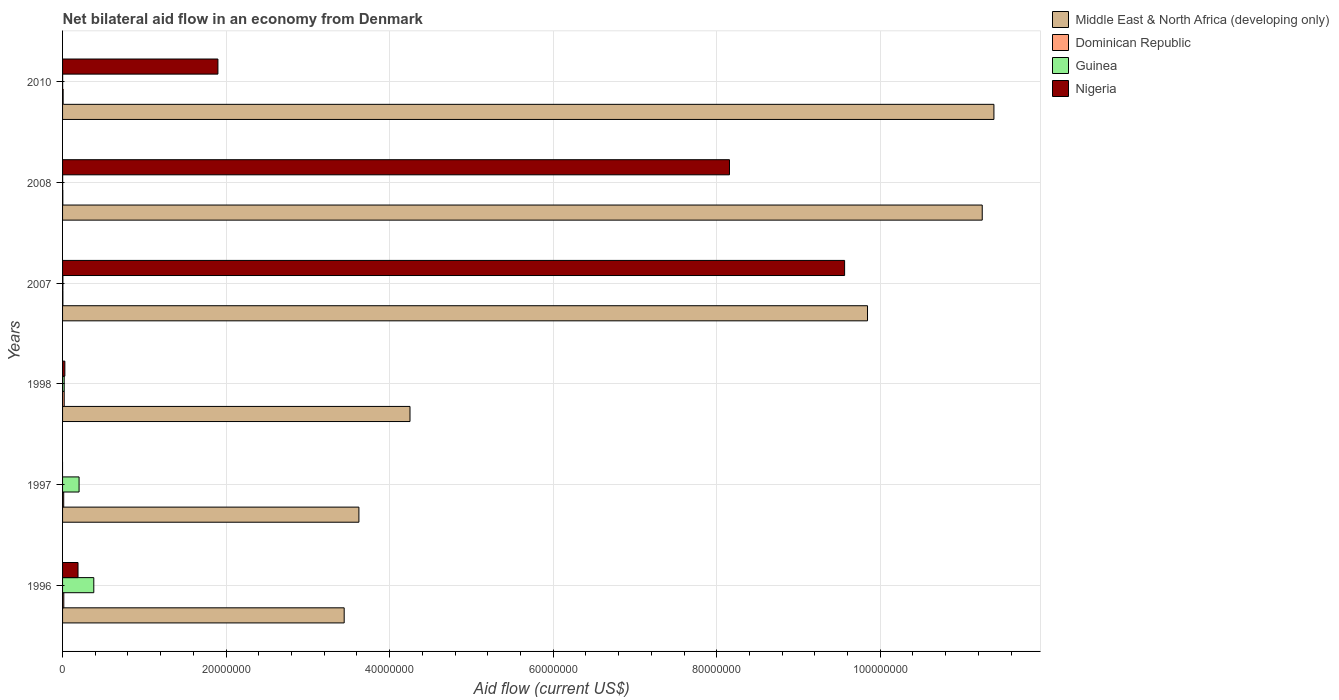How many different coloured bars are there?
Provide a short and direct response. 4. What is the net bilateral aid flow in Guinea in 1998?
Give a very brief answer. 2.00e+05. Across all years, what is the maximum net bilateral aid flow in Nigeria?
Give a very brief answer. 9.56e+07. Across all years, what is the minimum net bilateral aid flow in Dominican Republic?
Provide a succinct answer. 3.00e+04. What is the total net bilateral aid flow in Guinea in the graph?
Give a very brief answer. 6.10e+06. What is the difference between the net bilateral aid flow in Guinea in 1996 and that in 1998?
Provide a succinct answer. 3.62e+06. What is the difference between the net bilateral aid flow in Middle East & North Africa (developing only) in 2010 and the net bilateral aid flow in Guinea in 1997?
Provide a succinct answer. 1.12e+08. What is the average net bilateral aid flow in Dominican Republic per year?
Your answer should be very brief. 1.05e+05. In the year 1998, what is the difference between the net bilateral aid flow in Nigeria and net bilateral aid flow in Middle East & North Africa (developing only)?
Your response must be concise. -4.22e+07. In how many years, is the net bilateral aid flow in Nigeria greater than 16000000 US$?
Give a very brief answer. 3. What is the ratio of the net bilateral aid flow in Dominican Republic in 1998 to that in 2007?
Your response must be concise. 5. What is the difference between the highest and the second highest net bilateral aid flow in Nigeria?
Your answer should be very brief. 1.41e+07. Is the sum of the net bilateral aid flow in Dominican Republic in 1997 and 2010 greater than the maximum net bilateral aid flow in Guinea across all years?
Your answer should be compact. No. Is it the case that in every year, the sum of the net bilateral aid flow in Dominican Republic and net bilateral aid flow in Nigeria is greater than the sum of net bilateral aid flow in Guinea and net bilateral aid flow in Middle East & North Africa (developing only)?
Your response must be concise. No. Is it the case that in every year, the sum of the net bilateral aid flow in Dominican Republic and net bilateral aid flow in Guinea is greater than the net bilateral aid flow in Nigeria?
Offer a terse response. No. Are all the bars in the graph horizontal?
Provide a short and direct response. Yes. How many years are there in the graph?
Ensure brevity in your answer.  6. Does the graph contain any zero values?
Provide a succinct answer. Yes. Does the graph contain grids?
Ensure brevity in your answer.  Yes. How many legend labels are there?
Offer a terse response. 4. What is the title of the graph?
Ensure brevity in your answer.  Net bilateral aid flow in an economy from Denmark. What is the label or title of the Y-axis?
Your answer should be compact. Years. What is the Aid flow (current US$) of Middle East & North Africa (developing only) in 1996?
Your answer should be very brief. 3.44e+07. What is the Aid flow (current US$) of Guinea in 1996?
Provide a succinct answer. 3.82e+06. What is the Aid flow (current US$) in Nigeria in 1996?
Offer a very short reply. 1.89e+06. What is the Aid flow (current US$) in Middle East & North Africa (developing only) in 1997?
Make the answer very short. 3.62e+07. What is the Aid flow (current US$) of Guinea in 1997?
Ensure brevity in your answer.  2.02e+06. What is the Aid flow (current US$) of Middle East & North Africa (developing only) in 1998?
Give a very brief answer. 4.25e+07. What is the Aid flow (current US$) in Middle East & North Africa (developing only) in 2007?
Provide a short and direct response. 9.84e+07. What is the Aid flow (current US$) of Nigeria in 2007?
Ensure brevity in your answer.  9.56e+07. What is the Aid flow (current US$) of Middle East & North Africa (developing only) in 2008?
Keep it short and to the point. 1.12e+08. What is the Aid flow (current US$) in Nigeria in 2008?
Your response must be concise. 8.16e+07. What is the Aid flow (current US$) in Middle East & North Africa (developing only) in 2010?
Make the answer very short. 1.14e+08. What is the Aid flow (current US$) in Dominican Republic in 2010?
Keep it short and to the point. 7.00e+04. What is the Aid flow (current US$) of Guinea in 2010?
Your answer should be very brief. 10000. What is the Aid flow (current US$) in Nigeria in 2010?
Give a very brief answer. 1.90e+07. Across all years, what is the maximum Aid flow (current US$) of Middle East & North Africa (developing only)?
Your answer should be very brief. 1.14e+08. Across all years, what is the maximum Aid flow (current US$) in Guinea?
Make the answer very short. 3.82e+06. Across all years, what is the maximum Aid flow (current US$) of Nigeria?
Provide a short and direct response. 9.56e+07. Across all years, what is the minimum Aid flow (current US$) in Middle East & North Africa (developing only)?
Provide a short and direct response. 3.44e+07. What is the total Aid flow (current US$) in Middle East & North Africa (developing only) in the graph?
Your answer should be very brief. 4.38e+08. What is the total Aid flow (current US$) of Dominican Republic in the graph?
Offer a terse response. 6.30e+05. What is the total Aid flow (current US$) of Guinea in the graph?
Ensure brevity in your answer.  6.10e+06. What is the total Aid flow (current US$) in Nigeria in the graph?
Provide a succinct answer. 1.98e+08. What is the difference between the Aid flow (current US$) of Middle East & North Africa (developing only) in 1996 and that in 1997?
Give a very brief answer. -1.80e+06. What is the difference between the Aid flow (current US$) in Guinea in 1996 and that in 1997?
Offer a terse response. 1.80e+06. What is the difference between the Aid flow (current US$) of Middle East & North Africa (developing only) in 1996 and that in 1998?
Provide a short and direct response. -8.05e+06. What is the difference between the Aid flow (current US$) of Dominican Republic in 1996 and that in 1998?
Keep it short and to the point. -5.00e+04. What is the difference between the Aid flow (current US$) in Guinea in 1996 and that in 1998?
Make the answer very short. 3.62e+06. What is the difference between the Aid flow (current US$) in Nigeria in 1996 and that in 1998?
Provide a short and direct response. 1.61e+06. What is the difference between the Aid flow (current US$) of Middle East & North Africa (developing only) in 1996 and that in 2007?
Offer a very short reply. -6.40e+07. What is the difference between the Aid flow (current US$) of Dominican Republic in 1996 and that in 2007?
Provide a short and direct response. 1.10e+05. What is the difference between the Aid flow (current US$) in Guinea in 1996 and that in 2007?
Keep it short and to the point. 3.78e+06. What is the difference between the Aid flow (current US$) in Nigeria in 1996 and that in 2007?
Provide a short and direct response. -9.38e+07. What is the difference between the Aid flow (current US$) of Middle East & North Africa (developing only) in 1996 and that in 2008?
Give a very brief answer. -7.80e+07. What is the difference between the Aid flow (current US$) of Dominican Republic in 1996 and that in 2008?
Make the answer very short. 1.20e+05. What is the difference between the Aid flow (current US$) in Guinea in 1996 and that in 2008?
Keep it short and to the point. 3.81e+06. What is the difference between the Aid flow (current US$) in Nigeria in 1996 and that in 2008?
Ensure brevity in your answer.  -7.97e+07. What is the difference between the Aid flow (current US$) in Middle East & North Africa (developing only) in 1996 and that in 2010?
Provide a short and direct response. -7.95e+07. What is the difference between the Aid flow (current US$) of Dominican Republic in 1996 and that in 2010?
Your answer should be very brief. 8.00e+04. What is the difference between the Aid flow (current US$) of Guinea in 1996 and that in 2010?
Give a very brief answer. 3.81e+06. What is the difference between the Aid flow (current US$) of Nigeria in 1996 and that in 2010?
Provide a succinct answer. -1.71e+07. What is the difference between the Aid flow (current US$) in Middle East & North Africa (developing only) in 1997 and that in 1998?
Offer a terse response. -6.25e+06. What is the difference between the Aid flow (current US$) in Guinea in 1997 and that in 1998?
Keep it short and to the point. 1.82e+06. What is the difference between the Aid flow (current US$) of Middle East & North Africa (developing only) in 1997 and that in 2007?
Give a very brief answer. -6.22e+07. What is the difference between the Aid flow (current US$) in Dominican Republic in 1997 and that in 2007?
Provide a succinct answer. 1.00e+05. What is the difference between the Aid flow (current US$) in Guinea in 1997 and that in 2007?
Your answer should be compact. 1.98e+06. What is the difference between the Aid flow (current US$) of Middle East & North Africa (developing only) in 1997 and that in 2008?
Your response must be concise. -7.62e+07. What is the difference between the Aid flow (current US$) of Dominican Republic in 1997 and that in 2008?
Your answer should be very brief. 1.10e+05. What is the difference between the Aid flow (current US$) in Guinea in 1997 and that in 2008?
Make the answer very short. 2.01e+06. What is the difference between the Aid flow (current US$) in Middle East & North Africa (developing only) in 1997 and that in 2010?
Your answer should be compact. -7.77e+07. What is the difference between the Aid flow (current US$) in Guinea in 1997 and that in 2010?
Your response must be concise. 2.01e+06. What is the difference between the Aid flow (current US$) of Middle East & North Africa (developing only) in 1998 and that in 2007?
Keep it short and to the point. -5.60e+07. What is the difference between the Aid flow (current US$) of Nigeria in 1998 and that in 2007?
Provide a succinct answer. -9.54e+07. What is the difference between the Aid flow (current US$) of Middle East & North Africa (developing only) in 1998 and that in 2008?
Offer a very short reply. -7.00e+07. What is the difference between the Aid flow (current US$) of Dominican Republic in 1998 and that in 2008?
Keep it short and to the point. 1.70e+05. What is the difference between the Aid flow (current US$) in Guinea in 1998 and that in 2008?
Your answer should be compact. 1.90e+05. What is the difference between the Aid flow (current US$) of Nigeria in 1998 and that in 2008?
Your answer should be very brief. -8.13e+07. What is the difference between the Aid flow (current US$) of Middle East & North Africa (developing only) in 1998 and that in 2010?
Your answer should be very brief. -7.14e+07. What is the difference between the Aid flow (current US$) in Guinea in 1998 and that in 2010?
Your answer should be very brief. 1.90e+05. What is the difference between the Aid flow (current US$) in Nigeria in 1998 and that in 2010?
Your answer should be very brief. -1.87e+07. What is the difference between the Aid flow (current US$) of Middle East & North Africa (developing only) in 2007 and that in 2008?
Make the answer very short. -1.40e+07. What is the difference between the Aid flow (current US$) in Dominican Republic in 2007 and that in 2008?
Offer a very short reply. 10000. What is the difference between the Aid flow (current US$) of Guinea in 2007 and that in 2008?
Ensure brevity in your answer.  3.00e+04. What is the difference between the Aid flow (current US$) in Nigeria in 2007 and that in 2008?
Offer a terse response. 1.41e+07. What is the difference between the Aid flow (current US$) in Middle East & North Africa (developing only) in 2007 and that in 2010?
Offer a terse response. -1.55e+07. What is the difference between the Aid flow (current US$) of Dominican Republic in 2007 and that in 2010?
Your response must be concise. -3.00e+04. What is the difference between the Aid flow (current US$) of Nigeria in 2007 and that in 2010?
Make the answer very short. 7.66e+07. What is the difference between the Aid flow (current US$) in Middle East & North Africa (developing only) in 2008 and that in 2010?
Provide a succinct answer. -1.43e+06. What is the difference between the Aid flow (current US$) in Dominican Republic in 2008 and that in 2010?
Ensure brevity in your answer.  -4.00e+04. What is the difference between the Aid flow (current US$) of Guinea in 2008 and that in 2010?
Provide a succinct answer. 0. What is the difference between the Aid flow (current US$) of Nigeria in 2008 and that in 2010?
Give a very brief answer. 6.26e+07. What is the difference between the Aid flow (current US$) of Middle East & North Africa (developing only) in 1996 and the Aid flow (current US$) of Dominican Republic in 1997?
Make the answer very short. 3.43e+07. What is the difference between the Aid flow (current US$) in Middle East & North Africa (developing only) in 1996 and the Aid flow (current US$) in Guinea in 1997?
Offer a terse response. 3.24e+07. What is the difference between the Aid flow (current US$) in Dominican Republic in 1996 and the Aid flow (current US$) in Guinea in 1997?
Provide a succinct answer. -1.87e+06. What is the difference between the Aid flow (current US$) in Middle East & North Africa (developing only) in 1996 and the Aid flow (current US$) in Dominican Republic in 1998?
Make the answer very short. 3.42e+07. What is the difference between the Aid flow (current US$) of Middle East & North Africa (developing only) in 1996 and the Aid flow (current US$) of Guinea in 1998?
Your response must be concise. 3.42e+07. What is the difference between the Aid flow (current US$) of Middle East & North Africa (developing only) in 1996 and the Aid flow (current US$) of Nigeria in 1998?
Provide a short and direct response. 3.42e+07. What is the difference between the Aid flow (current US$) in Dominican Republic in 1996 and the Aid flow (current US$) in Guinea in 1998?
Make the answer very short. -5.00e+04. What is the difference between the Aid flow (current US$) in Guinea in 1996 and the Aid flow (current US$) in Nigeria in 1998?
Your response must be concise. 3.54e+06. What is the difference between the Aid flow (current US$) of Middle East & North Africa (developing only) in 1996 and the Aid flow (current US$) of Dominican Republic in 2007?
Provide a succinct answer. 3.44e+07. What is the difference between the Aid flow (current US$) of Middle East & North Africa (developing only) in 1996 and the Aid flow (current US$) of Guinea in 2007?
Ensure brevity in your answer.  3.44e+07. What is the difference between the Aid flow (current US$) of Middle East & North Africa (developing only) in 1996 and the Aid flow (current US$) of Nigeria in 2007?
Provide a succinct answer. -6.12e+07. What is the difference between the Aid flow (current US$) in Dominican Republic in 1996 and the Aid flow (current US$) in Guinea in 2007?
Your answer should be very brief. 1.10e+05. What is the difference between the Aid flow (current US$) in Dominican Republic in 1996 and the Aid flow (current US$) in Nigeria in 2007?
Provide a succinct answer. -9.55e+07. What is the difference between the Aid flow (current US$) in Guinea in 1996 and the Aid flow (current US$) in Nigeria in 2007?
Ensure brevity in your answer.  -9.18e+07. What is the difference between the Aid flow (current US$) of Middle East & North Africa (developing only) in 1996 and the Aid flow (current US$) of Dominican Republic in 2008?
Give a very brief answer. 3.44e+07. What is the difference between the Aid flow (current US$) of Middle East & North Africa (developing only) in 1996 and the Aid flow (current US$) of Guinea in 2008?
Offer a very short reply. 3.44e+07. What is the difference between the Aid flow (current US$) of Middle East & North Africa (developing only) in 1996 and the Aid flow (current US$) of Nigeria in 2008?
Offer a terse response. -4.71e+07. What is the difference between the Aid flow (current US$) in Dominican Republic in 1996 and the Aid flow (current US$) in Guinea in 2008?
Your answer should be compact. 1.40e+05. What is the difference between the Aid flow (current US$) of Dominican Republic in 1996 and the Aid flow (current US$) of Nigeria in 2008?
Ensure brevity in your answer.  -8.14e+07. What is the difference between the Aid flow (current US$) of Guinea in 1996 and the Aid flow (current US$) of Nigeria in 2008?
Provide a short and direct response. -7.77e+07. What is the difference between the Aid flow (current US$) of Middle East & North Africa (developing only) in 1996 and the Aid flow (current US$) of Dominican Republic in 2010?
Your answer should be compact. 3.44e+07. What is the difference between the Aid flow (current US$) of Middle East & North Africa (developing only) in 1996 and the Aid flow (current US$) of Guinea in 2010?
Your response must be concise. 3.44e+07. What is the difference between the Aid flow (current US$) of Middle East & North Africa (developing only) in 1996 and the Aid flow (current US$) of Nigeria in 2010?
Provide a succinct answer. 1.54e+07. What is the difference between the Aid flow (current US$) in Dominican Republic in 1996 and the Aid flow (current US$) in Guinea in 2010?
Your answer should be compact. 1.40e+05. What is the difference between the Aid flow (current US$) of Dominican Republic in 1996 and the Aid flow (current US$) of Nigeria in 2010?
Your answer should be compact. -1.88e+07. What is the difference between the Aid flow (current US$) in Guinea in 1996 and the Aid flow (current US$) in Nigeria in 2010?
Your answer should be compact. -1.52e+07. What is the difference between the Aid flow (current US$) in Middle East & North Africa (developing only) in 1997 and the Aid flow (current US$) in Dominican Republic in 1998?
Keep it short and to the point. 3.60e+07. What is the difference between the Aid flow (current US$) of Middle East & North Africa (developing only) in 1997 and the Aid flow (current US$) of Guinea in 1998?
Your response must be concise. 3.60e+07. What is the difference between the Aid flow (current US$) in Middle East & North Africa (developing only) in 1997 and the Aid flow (current US$) in Nigeria in 1998?
Keep it short and to the point. 3.60e+07. What is the difference between the Aid flow (current US$) in Dominican Republic in 1997 and the Aid flow (current US$) in Guinea in 1998?
Your answer should be compact. -6.00e+04. What is the difference between the Aid flow (current US$) of Guinea in 1997 and the Aid flow (current US$) of Nigeria in 1998?
Keep it short and to the point. 1.74e+06. What is the difference between the Aid flow (current US$) in Middle East & North Africa (developing only) in 1997 and the Aid flow (current US$) in Dominican Republic in 2007?
Keep it short and to the point. 3.62e+07. What is the difference between the Aid flow (current US$) in Middle East & North Africa (developing only) in 1997 and the Aid flow (current US$) in Guinea in 2007?
Your answer should be very brief. 3.62e+07. What is the difference between the Aid flow (current US$) of Middle East & North Africa (developing only) in 1997 and the Aid flow (current US$) of Nigeria in 2007?
Give a very brief answer. -5.94e+07. What is the difference between the Aid flow (current US$) of Dominican Republic in 1997 and the Aid flow (current US$) of Guinea in 2007?
Give a very brief answer. 1.00e+05. What is the difference between the Aid flow (current US$) of Dominican Republic in 1997 and the Aid flow (current US$) of Nigeria in 2007?
Ensure brevity in your answer.  -9.55e+07. What is the difference between the Aid flow (current US$) of Guinea in 1997 and the Aid flow (current US$) of Nigeria in 2007?
Give a very brief answer. -9.36e+07. What is the difference between the Aid flow (current US$) in Middle East & North Africa (developing only) in 1997 and the Aid flow (current US$) in Dominican Republic in 2008?
Your response must be concise. 3.62e+07. What is the difference between the Aid flow (current US$) in Middle East & North Africa (developing only) in 1997 and the Aid flow (current US$) in Guinea in 2008?
Make the answer very short. 3.62e+07. What is the difference between the Aid flow (current US$) of Middle East & North Africa (developing only) in 1997 and the Aid flow (current US$) of Nigeria in 2008?
Ensure brevity in your answer.  -4.53e+07. What is the difference between the Aid flow (current US$) in Dominican Republic in 1997 and the Aid flow (current US$) in Nigeria in 2008?
Give a very brief answer. -8.14e+07. What is the difference between the Aid flow (current US$) in Guinea in 1997 and the Aid flow (current US$) in Nigeria in 2008?
Your answer should be compact. -7.95e+07. What is the difference between the Aid flow (current US$) in Middle East & North Africa (developing only) in 1997 and the Aid flow (current US$) in Dominican Republic in 2010?
Ensure brevity in your answer.  3.62e+07. What is the difference between the Aid flow (current US$) of Middle East & North Africa (developing only) in 1997 and the Aid flow (current US$) of Guinea in 2010?
Offer a terse response. 3.62e+07. What is the difference between the Aid flow (current US$) in Middle East & North Africa (developing only) in 1997 and the Aid flow (current US$) in Nigeria in 2010?
Your answer should be compact. 1.72e+07. What is the difference between the Aid flow (current US$) of Dominican Republic in 1997 and the Aid flow (current US$) of Nigeria in 2010?
Provide a short and direct response. -1.89e+07. What is the difference between the Aid flow (current US$) of Guinea in 1997 and the Aid flow (current US$) of Nigeria in 2010?
Your response must be concise. -1.70e+07. What is the difference between the Aid flow (current US$) of Middle East & North Africa (developing only) in 1998 and the Aid flow (current US$) of Dominican Republic in 2007?
Keep it short and to the point. 4.24e+07. What is the difference between the Aid flow (current US$) of Middle East & North Africa (developing only) in 1998 and the Aid flow (current US$) of Guinea in 2007?
Provide a short and direct response. 4.24e+07. What is the difference between the Aid flow (current US$) of Middle East & North Africa (developing only) in 1998 and the Aid flow (current US$) of Nigeria in 2007?
Make the answer very short. -5.32e+07. What is the difference between the Aid flow (current US$) in Dominican Republic in 1998 and the Aid flow (current US$) in Guinea in 2007?
Offer a terse response. 1.60e+05. What is the difference between the Aid flow (current US$) in Dominican Republic in 1998 and the Aid flow (current US$) in Nigeria in 2007?
Keep it short and to the point. -9.54e+07. What is the difference between the Aid flow (current US$) in Guinea in 1998 and the Aid flow (current US$) in Nigeria in 2007?
Your response must be concise. -9.54e+07. What is the difference between the Aid flow (current US$) of Middle East & North Africa (developing only) in 1998 and the Aid flow (current US$) of Dominican Republic in 2008?
Provide a succinct answer. 4.25e+07. What is the difference between the Aid flow (current US$) in Middle East & North Africa (developing only) in 1998 and the Aid flow (current US$) in Guinea in 2008?
Make the answer very short. 4.25e+07. What is the difference between the Aid flow (current US$) of Middle East & North Africa (developing only) in 1998 and the Aid flow (current US$) of Nigeria in 2008?
Your answer should be very brief. -3.91e+07. What is the difference between the Aid flow (current US$) of Dominican Republic in 1998 and the Aid flow (current US$) of Nigeria in 2008?
Offer a very short reply. -8.14e+07. What is the difference between the Aid flow (current US$) of Guinea in 1998 and the Aid flow (current US$) of Nigeria in 2008?
Keep it short and to the point. -8.14e+07. What is the difference between the Aid flow (current US$) of Middle East & North Africa (developing only) in 1998 and the Aid flow (current US$) of Dominican Republic in 2010?
Make the answer very short. 4.24e+07. What is the difference between the Aid flow (current US$) in Middle East & North Africa (developing only) in 1998 and the Aid flow (current US$) in Guinea in 2010?
Keep it short and to the point. 4.25e+07. What is the difference between the Aid flow (current US$) of Middle East & North Africa (developing only) in 1998 and the Aid flow (current US$) of Nigeria in 2010?
Give a very brief answer. 2.35e+07. What is the difference between the Aid flow (current US$) of Dominican Republic in 1998 and the Aid flow (current US$) of Nigeria in 2010?
Offer a very short reply. -1.88e+07. What is the difference between the Aid flow (current US$) in Guinea in 1998 and the Aid flow (current US$) in Nigeria in 2010?
Provide a short and direct response. -1.88e+07. What is the difference between the Aid flow (current US$) of Middle East & North Africa (developing only) in 2007 and the Aid flow (current US$) of Dominican Republic in 2008?
Ensure brevity in your answer.  9.84e+07. What is the difference between the Aid flow (current US$) of Middle East & North Africa (developing only) in 2007 and the Aid flow (current US$) of Guinea in 2008?
Keep it short and to the point. 9.84e+07. What is the difference between the Aid flow (current US$) in Middle East & North Africa (developing only) in 2007 and the Aid flow (current US$) in Nigeria in 2008?
Give a very brief answer. 1.69e+07. What is the difference between the Aid flow (current US$) of Dominican Republic in 2007 and the Aid flow (current US$) of Nigeria in 2008?
Ensure brevity in your answer.  -8.15e+07. What is the difference between the Aid flow (current US$) in Guinea in 2007 and the Aid flow (current US$) in Nigeria in 2008?
Provide a short and direct response. -8.15e+07. What is the difference between the Aid flow (current US$) of Middle East & North Africa (developing only) in 2007 and the Aid flow (current US$) of Dominican Republic in 2010?
Keep it short and to the point. 9.84e+07. What is the difference between the Aid flow (current US$) in Middle East & North Africa (developing only) in 2007 and the Aid flow (current US$) in Guinea in 2010?
Make the answer very short. 9.84e+07. What is the difference between the Aid flow (current US$) of Middle East & North Africa (developing only) in 2007 and the Aid flow (current US$) of Nigeria in 2010?
Provide a short and direct response. 7.94e+07. What is the difference between the Aid flow (current US$) of Dominican Republic in 2007 and the Aid flow (current US$) of Nigeria in 2010?
Your response must be concise. -1.90e+07. What is the difference between the Aid flow (current US$) in Guinea in 2007 and the Aid flow (current US$) in Nigeria in 2010?
Provide a short and direct response. -1.90e+07. What is the difference between the Aid flow (current US$) in Middle East & North Africa (developing only) in 2008 and the Aid flow (current US$) in Dominican Republic in 2010?
Provide a succinct answer. 1.12e+08. What is the difference between the Aid flow (current US$) in Middle East & North Africa (developing only) in 2008 and the Aid flow (current US$) in Guinea in 2010?
Make the answer very short. 1.12e+08. What is the difference between the Aid flow (current US$) of Middle East & North Africa (developing only) in 2008 and the Aid flow (current US$) of Nigeria in 2010?
Keep it short and to the point. 9.35e+07. What is the difference between the Aid flow (current US$) in Dominican Republic in 2008 and the Aid flow (current US$) in Guinea in 2010?
Your answer should be very brief. 2.00e+04. What is the difference between the Aid flow (current US$) in Dominican Republic in 2008 and the Aid flow (current US$) in Nigeria in 2010?
Your answer should be very brief. -1.90e+07. What is the difference between the Aid flow (current US$) in Guinea in 2008 and the Aid flow (current US$) in Nigeria in 2010?
Your answer should be very brief. -1.90e+07. What is the average Aid flow (current US$) of Middle East & North Africa (developing only) per year?
Keep it short and to the point. 7.30e+07. What is the average Aid flow (current US$) of Dominican Republic per year?
Provide a succinct answer. 1.05e+05. What is the average Aid flow (current US$) of Guinea per year?
Give a very brief answer. 1.02e+06. What is the average Aid flow (current US$) in Nigeria per year?
Offer a terse response. 3.31e+07. In the year 1996, what is the difference between the Aid flow (current US$) in Middle East & North Africa (developing only) and Aid flow (current US$) in Dominican Republic?
Provide a succinct answer. 3.43e+07. In the year 1996, what is the difference between the Aid flow (current US$) of Middle East & North Africa (developing only) and Aid flow (current US$) of Guinea?
Your response must be concise. 3.06e+07. In the year 1996, what is the difference between the Aid flow (current US$) of Middle East & North Africa (developing only) and Aid flow (current US$) of Nigeria?
Your answer should be compact. 3.26e+07. In the year 1996, what is the difference between the Aid flow (current US$) of Dominican Republic and Aid flow (current US$) of Guinea?
Offer a very short reply. -3.67e+06. In the year 1996, what is the difference between the Aid flow (current US$) in Dominican Republic and Aid flow (current US$) in Nigeria?
Your answer should be compact. -1.74e+06. In the year 1996, what is the difference between the Aid flow (current US$) in Guinea and Aid flow (current US$) in Nigeria?
Provide a succinct answer. 1.93e+06. In the year 1997, what is the difference between the Aid flow (current US$) in Middle East & North Africa (developing only) and Aid flow (current US$) in Dominican Republic?
Your response must be concise. 3.61e+07. In the year 1997, what is the difference between the Aid flow (current US$) in Middle East & North Africa (developing only) and Aid flow (current US$) in Guinea?
Give a very brief answer. 3.42e+07. In the year 1997, what is the difference between the Aid flow (current US$) of Dominican Republic and Aid flow (current US$) of Guinea?
Make the answer very short. -1.88e+06. In the year 1998, what is the difference between the Aid flow (current US$) in Middle East & North Africa (developing only) and Aid flow (current US$) in Dominican Republic?
Your response must be concise. 4.23e+07. In the year 1998, what is the difference between the Aid flow (current US$) in Middle East & North Africa (developing only) and Aid flow (current US$) in Guinea?
Your answer should be compact. 4.23e+07. In the year 1998, what is the difference between the Aid flow (current US$) of Middle East & North Africa (developing only) and Aid flow (current US$) of Nigeria?
Provide a short and direct response. 4.22e+07. In the year 1998, what is the difference between the Aid flow (current US$) in Dominican Republic and Aid flow (current US$) in Nigeria?
Keep it short and to the point. -8.00e+04. In the year 1998, what is the difference between the Aid flow (current US$) of Guinea and Aid flow (current US$) of Nigeria?
Make the answer very short. -8.00e+04. In the year 2007, what is the difference between the Aid flow (current US$) in Middle East & North Africa (developing only) and Aid flow (current US$) in Dominican Republic?
Make the answer very short. 9.84e+07. In the year 2007, what is the difference between the Aid flow (current US$) of Middle East & North Africa (developing only) and Aid flow (current US$) of Guinea?
Make the answer very short. 9.84e+07. In the year 2007, what is the difference between the Aid flow (current US$) in Middle East & North Africa (developing only) and Aid flow (current US$) in Nigeria?
Ensure brevity in your answer.  2.80e+06. In the year 2007, what is the difference between the Aid flow (current US$) of Dominican Republic and Aid flow (current US$) of Guinea?
Your answer should be very brief. 0. In the year 2007, what is the difference between the Aid flow (current US$) in Dominican Republic and Aid flow (current US$) in Nigeria?
Provide a short and direct response. -9.56e+07. In the year 2007, what is the difference between the Aid flow (current US$) in Guinea and Aid flow (current US$) in Nigeria?
Ensure brevity in your answer.  -9.56e+07. In the year 2008, what is the difference between the Aid flow (current US$) in Middle East & North Africa (developing only) and Aid flow (current US$) in Dominican Republic?
Your answer should be very brief. 1.12e+08. In the year 2008, what is the difference between the Aid flow (current US$) of Middle East & North Africa (developing only) and Aid flow (current US$) of Guinea?
Provide a succinct answer. 1.12e+08. In the year 2008, what is the difference between the Aid flow (current US$) of Middle East & North Africa (developing only) and Aid flow (current US$) of Nigeria?
Keep it short and to the point. 3.09e+07. In the year 2008, what is the difference between the Aid flow (current US$) in Dominican Republic and Aid flow (current US$) in Guinea?
Your answer should be very brief. 2.00e+04. In the year 2008, what is the difference between the Aid flow (current US$) in Dominican Republic and Aid flow (current US$) in Nigeria?
Give a very brief answer. -8.15e+07. In the year 2008, what is the difference between the Aid flow (current US$) in Guinea and Aid flow (current US$) in Nigeria?
Make the answer very short. -8.16e+07. In the year 2010, what is the difference between the Aid flow (current US$) in Middle East & North Africa (developing only) and Aid flow (current US$) in Dominican Republic?
Keep it short and to the point. 1.14e+08. In the year 2010, what is the difference between the Aid flow (current US$) in Middle East & North Africa (developing only) and Aid flow (current US$) in Guinea?
Your answer should be compact. 1.14e+08. In the year 2010, what is the difference between the Aid flow (current US$) of Middle East & North Africa (developing only) and Aid flow (current US$) of Nigeria?
Ensure brevity in your answer.  9.49e+07. In the year 2010, what is the difference between the Aid flow (current US$) in Dominican Republic and Aid flow (current US$) in Guinea?
Your response must be concise. 6.00e+04. In the year 2010, what is the difference between the Aid flow (current US$) in Dominican Republic and Aid flow (current US$) in Nigeria?
Your answer should be compact. -1.89e+07. In the year 2010, what is the difference between the Aid flow (current US$) of Guinea and Aid flow (current US$) of Nigeria?
Provide a short and direct response. -1.90e+07. What is the ratio of the Aid flow (current US$) of Middle East & North Africa (developing only) in 1996 to that in 1997?
Ensure brevity in your answer.  0.95. What is the ratio of the Aid flow (current US$) of Dominican Republic in 1996 to that in 1997?
Make the answer very short. 1.07. What is the ratio of the Aid flow (current US$) of Guinea in 1996 to that in 1997?
Ensure brevity in your answer.  1.89. What is the ratio of the Aid flow (current US$) of Middle East & North Africa (developing only) in 1996 to that in 1998?
Give a very brief answer. 0.81. What is the ratio of the Aid flow (current US$) of Guinea in 1996 to that in 1998?
Ensure brevity in your answer.  19.1. What is the ratio of the Aid flow (current US$) in Nigeria in 1996 to that in 1998?
Provide a short and direct response. 6.75. What is the ratio of the Aid flow (current US$) in Middle East & North Africa (developing only) in 1996 to that in 2007?
Provide a short and direct response. 0.35. What is the ratio of the Aid flow (current US$) in Dominican Republic in 1996 to that in 2007?
Make the answer very short. 3.75. What is the ratio of the Aid flow (current US$) in Guinea in 1996 to that in 2007?
Keep it short and to the point. 95.5. What is the ratio of the Aid flow (current US$) of Nigeria in 1996 to that in 2007?
Keep it short and to the point. 0.02. What is the ratio of the Aid flow (current US$) in Middle East & North Africa (developing only) in 1996 to that in 2008?
Ensure brevity in your answer.  0.31. What is the ratio of the Aid flow (current US$) of Dominican Republic in 1996 to that in 2008?
Offer a terse response. 5. What is the ratio of the Aid flow (current US$) of Guinea in 1996 to that in 2008?
Your response must be concise. 382. What is the ratio of the Aid flow (current US$) of Nigeria in 1996 to that in 2008?
Keep it short and to the point. 0.02. What is the ratio of the Aid flow (current US$) in Middle East & North Africa (developing only) in 1996 to that in 2010?
Your answer should be compact. 0.3. What is the ratio of the Aid flow (current US$) of Dominican Republic in 1996 to that in 2010?
Offer a very short reply. 2.14. What is the ratio of the Aid flow (current US$) in Guinea in 1996 to that in 2010?
Your response must be concise. 382. What is the ratio of the Aid flow (current US$) in Nigeria in 1996 to that in 2010?
Offer a terse response. 0.1. What is the ratio of the Aid flow (current US$) of Middle East & North Africa (developing only) in 1997 to that in 1998?
Your response must be concise. 0.85. What is the ratio of the Aid flow (current US$) of Guinea in 1997 to that in 1998?
Keep it short and to the point. 10.1. What is the ratio of the Aid flow (current US$) of Middle East & North Africa (developing only) in 1997 to that in 2007?
Make the answer very short. 0.37. What is the ratio of the Aid flow (current US$) in Dominican Republic in 1997 to that in 2007?
Offer a terse response. 3.5. What is the ratio of the Aid flow (current US$) of Guinea in 1997 to that in 2007?
Provide a short and direct response. 50.5. What is the ratio of the Aid flow (current US$) in Middle East & North Africa (developing only) in 1997 to that in 2008?
Give a very brief answer. 0.32. What is the ratio of the Aid flow (current US$) in Dominican Republic in 1997 to that in 2008?
Make the answer very short. 4.67. What is the ratio of the Aid flow (current US$) in Guinea in 1997 to that in 2008?
Give a very brief answer. 202. What is the ratio of the Aid flow (current US$) in Middle East & North Africa (developing only) in 1997 to that in 2010?
Provide a succinct answer. 0.32. What is the ratio of the Aid flow (current US$) of Guinea in 1997 to that in 2010?
Your response must be concise. 202. What is the ratio of the Aid flow (current US$) of Middle East & North Africa (developing only) in 1998 to that in 2007?
Keep it short and to the point. 0.43. What is the ratio of the Aid flow (current US$) of Nigeria in 1998 to that in 2007?
Offer a very short reply. 0. What is the ratio of the Aid flow (current US$) of Middle East & North Africa (developing only) in 1998 to that in 2008?
Keep it short and to the point. 0.38. What is the ratio of the Aid flow (current US$) in Dominican Republic in 1998 to that in 2008?
Offer a terse response. 6.67. What is the ratio of the Aid flow (current US$) in Guinea in 1998 to that in 2008?
Keep it short and to the point. 20. What is the ratio of the Aid flow (current US$) in Nigeria in 1998 to that in 2008?
Ensure brevity in your answer.  0. What is the ratio of the Aid flow (current US$) in Middle East & North Africa (developing only) in 1998 to that in 2010?
Ensure brevity in your answer.  0.37. What is the ratio of the Aid flow (current US$) in Dominican Republic in 1998 to that in 2010?
Provide a succinct answer. 2.86. What is the ratio of the Aid flow (current US$) of Nigeria in 1998 to that in 2010?
Give a very brief answer. 0.01. What is the ratio of the Aid flow (current US$) of Middle East & North Africa (developing only) in 2007 to that in 2008?
Provide a succinct answer. 0.88. What is the ratio of the Aid flow (current US$) in Dominican Republic in 2007 to that in 2008?
Give a very brief answer. 1.33. What is the ratio of the Aid flow (current US$) in Guinea in 2007 to that in 2008?
Keep it short and to the point. 4. What is the ratio of the Aid flow (current US$) of Nigeria in 2007 to that in 2008?
Provide a succinct answer. 1.17. What is the ratio of the Aid flow (current US$) of Middle East & North Africa (developing only) in 2007 to that in 2010?
Keep it short and to the point. 0.86. What is the ratio of the Aid flow (current US$) in Dominican Republic in 2007 to that in 2010?
Make the answer very short. 0.57. What is the ratio of the Aid flow (current US$) in Guinea in 2007 to that in 2010?
Give a very brief answer. 4. What is the ratio of the Aid flow (current US$) of Nigeria in 2007 to that in 2010?
Keep it short and to the point. 5.03. What is the ratio of the Aid flow (current US$) in Middle East & North Africa (developing only) in 2008 to that in 2010?
Make the answer very short. 0.99. What is the ratio of the Aid flow (current US$) in Dominican Republic in 2008 to that in 2010?
Give a very brief answer. 0.43. What is the ratio of the Aid flow (current US$) of Nigeria in 2008 to that in 2010?
Provide a succinct answer. 4.29. What is the difference between the highest and the second highest Aid flow (current US$) of Middle East & North Africa (developing only)?
Offer a terse response. 1.43e+06. What is the difference between the highest and the second highest Aid flow (current US$) of Guinea?
Ensure brevity in your answer.  1.80e+06. What is the difference between the highest and the second highest Aid flow (current US$) of Nigeria?
Keep it short and to the point. 1.41e+07. What is the difference between the highest and the lowest Aid flow (current US$) in Middle East & North Africa (developing only)?
Make the answer very short. 7.95e+07. What is the difference between the highest and the lowest Aid flow (current US$) of Dominican Republic?
Provide a short and direct response. 1.70e+05. What is the difference between the highest and the lowest Aid flow (current US$) of Guinea?
Provide a short and direct response. 3.81e+06. What is the difference between the highest and the lowest Aid flow (current US$) in Nigeria?
Your answer should be compact. 9.56e+07. 